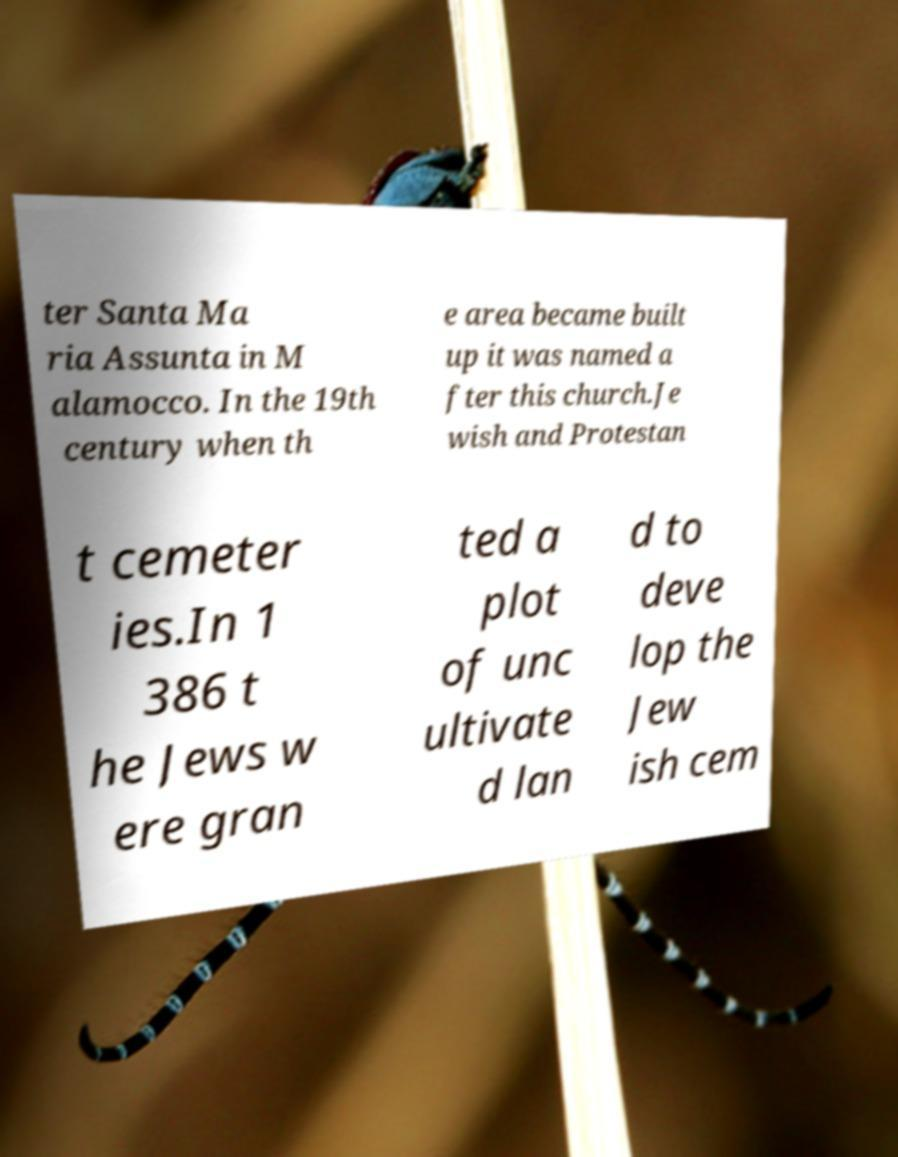Can you read and provide the text displayed in the image?This photo seems to have some interesting text. Can you extract and type it out for me? ter Santa Ma ria Assunta in M alamocco. In the 19th century when th e area became built up it was named a fter this church.Je wish and Protestan t cemeter ies.In 1 386 t he Jews w ere gran ted a plot of unc ultivate d lan d to deve lop the Jew ish cem 